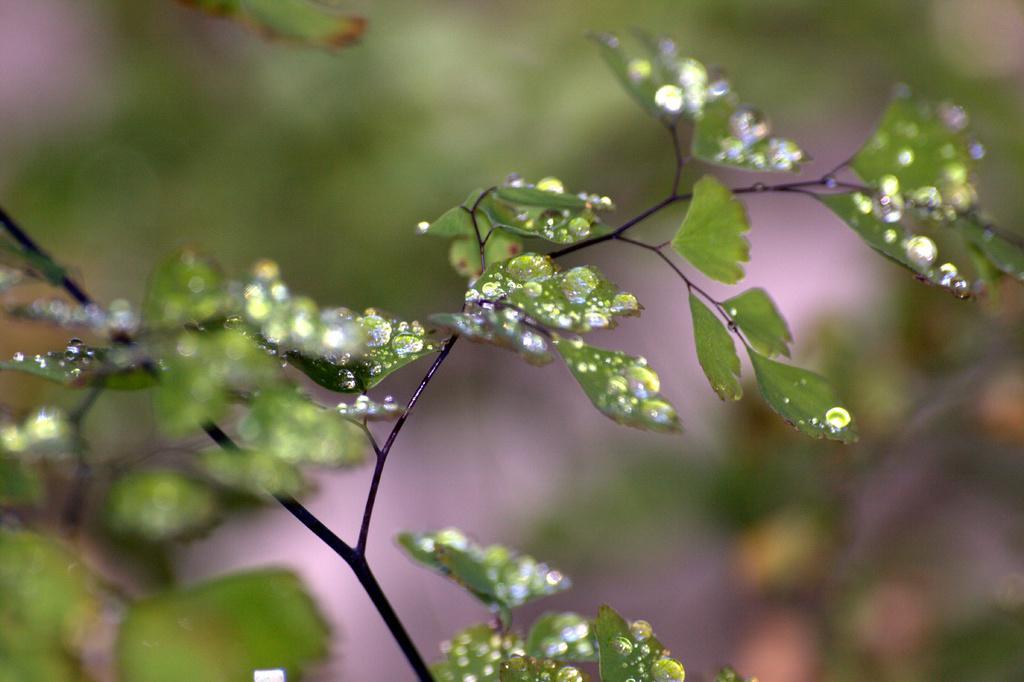In one or two sentences, can you explain what this image depicts? In this image, we can see planets with water droplets. 